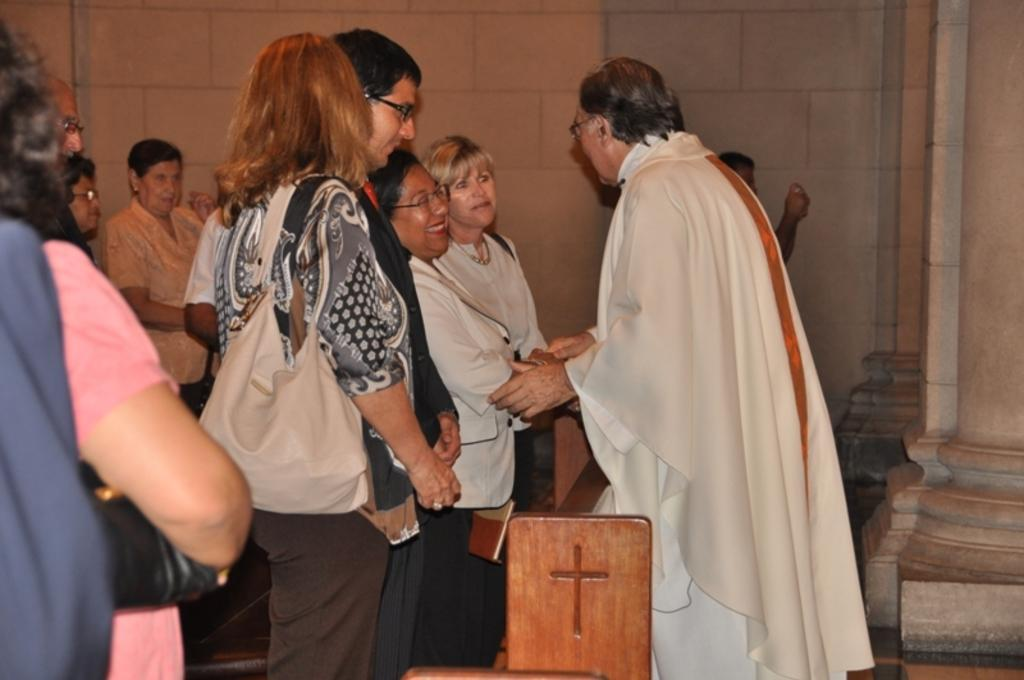How many people are in the image? There are people in the image, but the exact number is not specified. What is one person doing in the image? One person is carrying a bag. What type of object can be seen in the image? There is a wooden object in the image. What can be seen in the background of the image? There is a wall and pillars in the background of the image. What type of education is being taught by the dolls in the image? There are no dolls present in the image, so it is not possible to determine what type of education they might be teaching. 